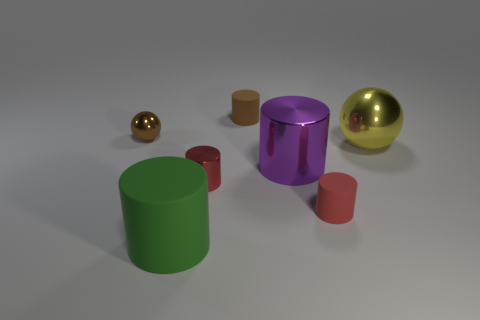What is the shape of the tiny rubber object behind the small shiny object on the left side of the large green rubber thing?
Offer a very short reply. Cylinder. Is there a small red metallic sphere?
Your answer should be very brief. No. The matte object behind the brown ball is what color?
Your answer should be compact. Brown. There is a object that is the same color as the tiny sphere; what is its material?
Provide a short and direct response. Rubber. There is a green rubber object; are there any brown cylinders in front of it?
Provide a short and direct response. No. Is the number of brown matte cylinders greater than the number of tiny cyan shiny balls?
Ensure brevity in your answer.  Yes. There is a rubber thing that is on the left side of the brown thing that is behind the brown sphere that is to the left of the green matte object; what is its color?
Your answer should be very brief. Green. What is the color of the cylinder that is the same material as the purple thing?
Keep it short and to the point. Red. How many objects are either tiny rubber things that are in front of the small brown rubber thing or things that are behind the big green thing?
Your answer should be very brief. 6. There is a purple cylinder that is behind the red matte object; does it have the same size as the brown metal sphere that is behind the green object?
Offer a terse response. No. 